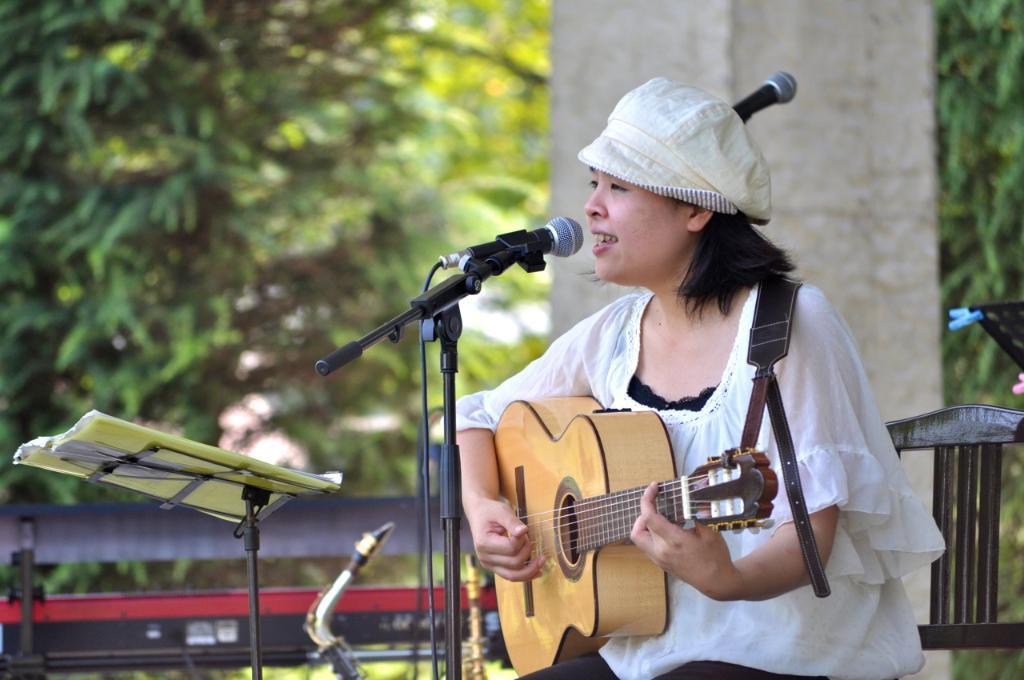Can you describe this image briefly? In this image i can see a woman holding a guitar and singing in front of a micro phone at the back ground i can see a pillar and a tree. 